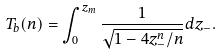Convert formula to latex. <formula><loc_0><loc_0><loc_500><loc_500>T _ { b } ( n ) = \int _ { 0 } ^ { z _ { m } } \frac { 1 } { \sqrt { 1 - 4 z _ { - } ^ { n } / n } } d z _ { - } .</formula> 